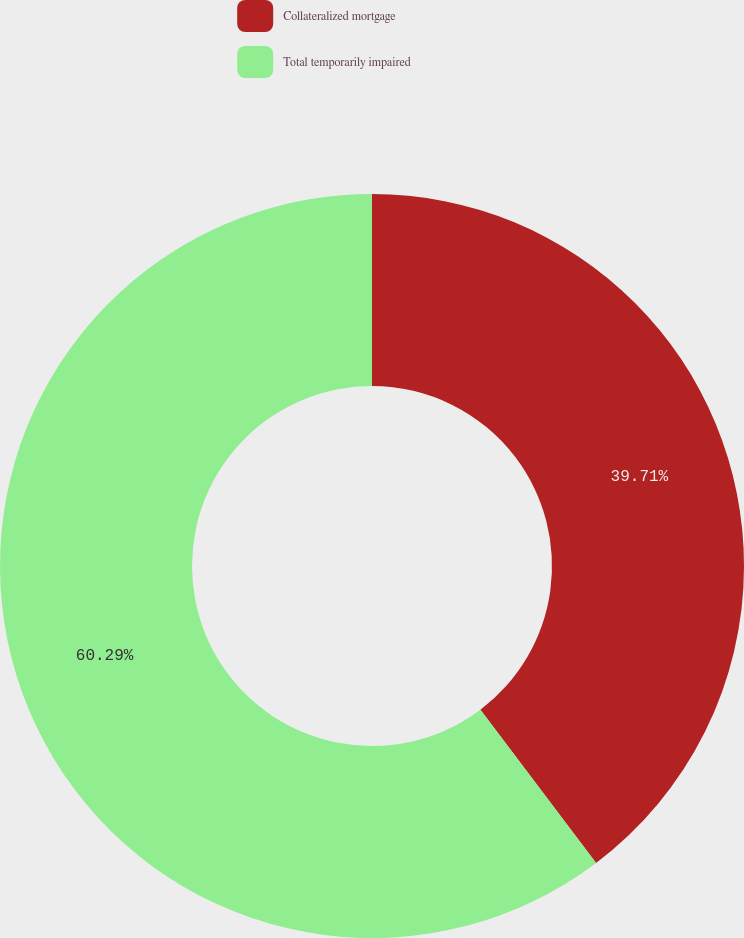Convert chart to OTSL. <chart><loc_0><loc_0><loc_500><loc_500><pie_chart><fcel>Collateralized mortgage<fcel>Total temporarily impaired<nl><fcel>39.71%<fcel>60.29%<nl></chart> 